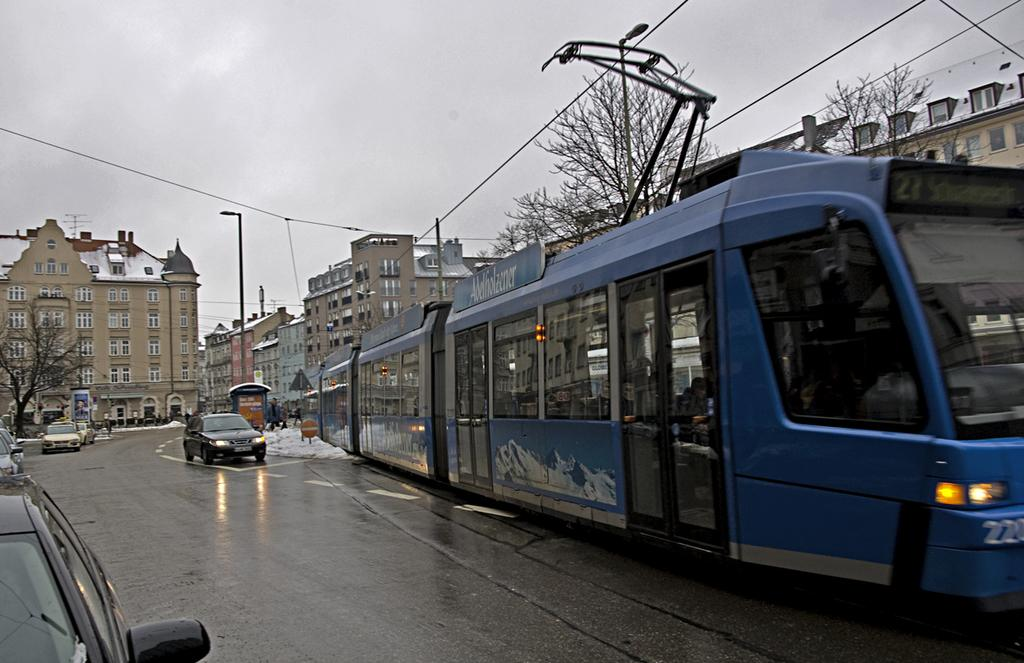What is the main subject of the image? There is a train in the image. On which side of the image is the train located? The train is on the right side of the image. What else can be seen in the image besides the train? There are cars on the road beside the train, buildings in the background, trees in front of the buildings, and the sky visible above the buildings. Can you see any giraffes walking on the train tracks in the image? No, there are no giraffes present in the image. How many planes can be seen flying in the sky above the buildings? There are no planes visible in the sky above the buildings in the image. 